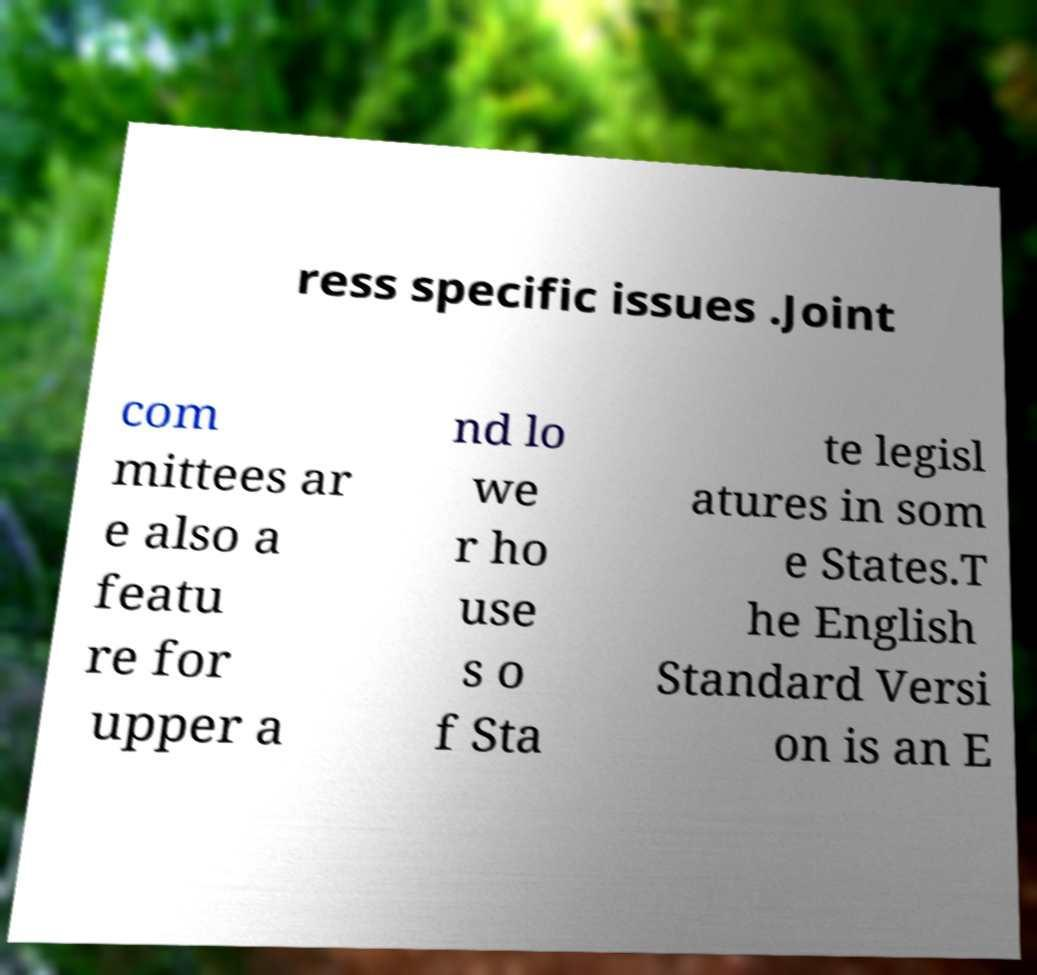I need the written content from this picture converted into text. Can you do that? ress specific issues .Joint com mittees ar e also a featu re for upper a nd lo we r ho use s o f Sta te legisl atures in som e States.T he English Standard Versi on is an E 